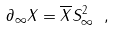Convert formula to latex. <formula><loc_0><loc_0><loc_500><loc_500>\partial _ { \infty } X = \overline { X } S _ { \infty } ^ { 2 } \ ,</formula> 